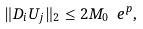<formula> <loc_0><loc_0><loc_500><loc_500>\| D _ { i } U _ { j } \| _ { 2 } \leq 2 M _ { 0 } \ e ^ { p } ,</formula> 